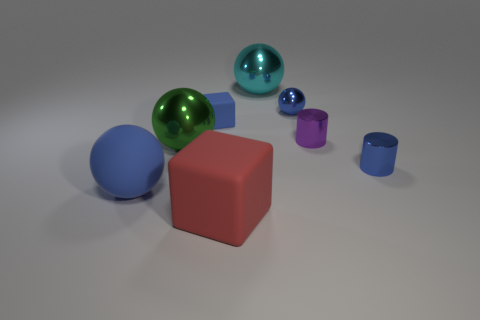Is the number of shiny spheres greater than the number of purple things?
Your response must be concise. Yes. The metal sphere that is in front of the purple shiny object is what color?
Your response must be concise. Green. There is a blue object that is both left of the tiny purple metal thing and on the right side of the small matte thing; how big is it?
Offer a very short reply. Small. What number of other rubber objects are the same size as the purple thing?
Offer a terse response. 1. What material is the blue object that is the same shape as the red object?
Keep it short and to the point. Rubber. Do the cyan shiny thing and the large blue matte thing have the same shape?
Offer a terse response. Yes. There is a tiny purple shiny cylinder; how many blocks are in front of it?
Keep it short and to the point. 1. What shape is the large object that is behind the tiny blue cube behind the green shiny object?
Provide a succinct answer. Sphere. There is a cyan object that is made of the same material as the green sphere; what is its shape?
Your answer should be very brief. Sphere. There is a blue matte thing that is in front of the small purple shiny cylinder; is its size the same as the blue ball to the right of the tiny matte block?
Offer a very short reply. No. 